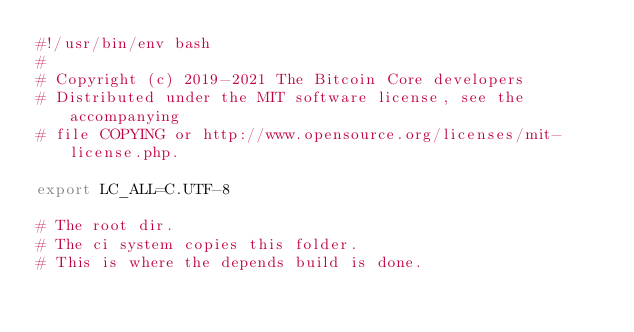<code> <loc_0><loc_0><loc_500><loc_500><_Bash_>#!/usr/bin/env bash
#
# Copyright (c) 2019-2021 The Bitcoin Core developers
# Distributed under the MIT software license, see the accompanying
# file COPYING or http://www.opensource.org/licenses/mit-license.php.

export LC_ALL=C.UTF-8

# The root dir.
# The ci system copies this folder.
# This is where the depends build is done.</code> 